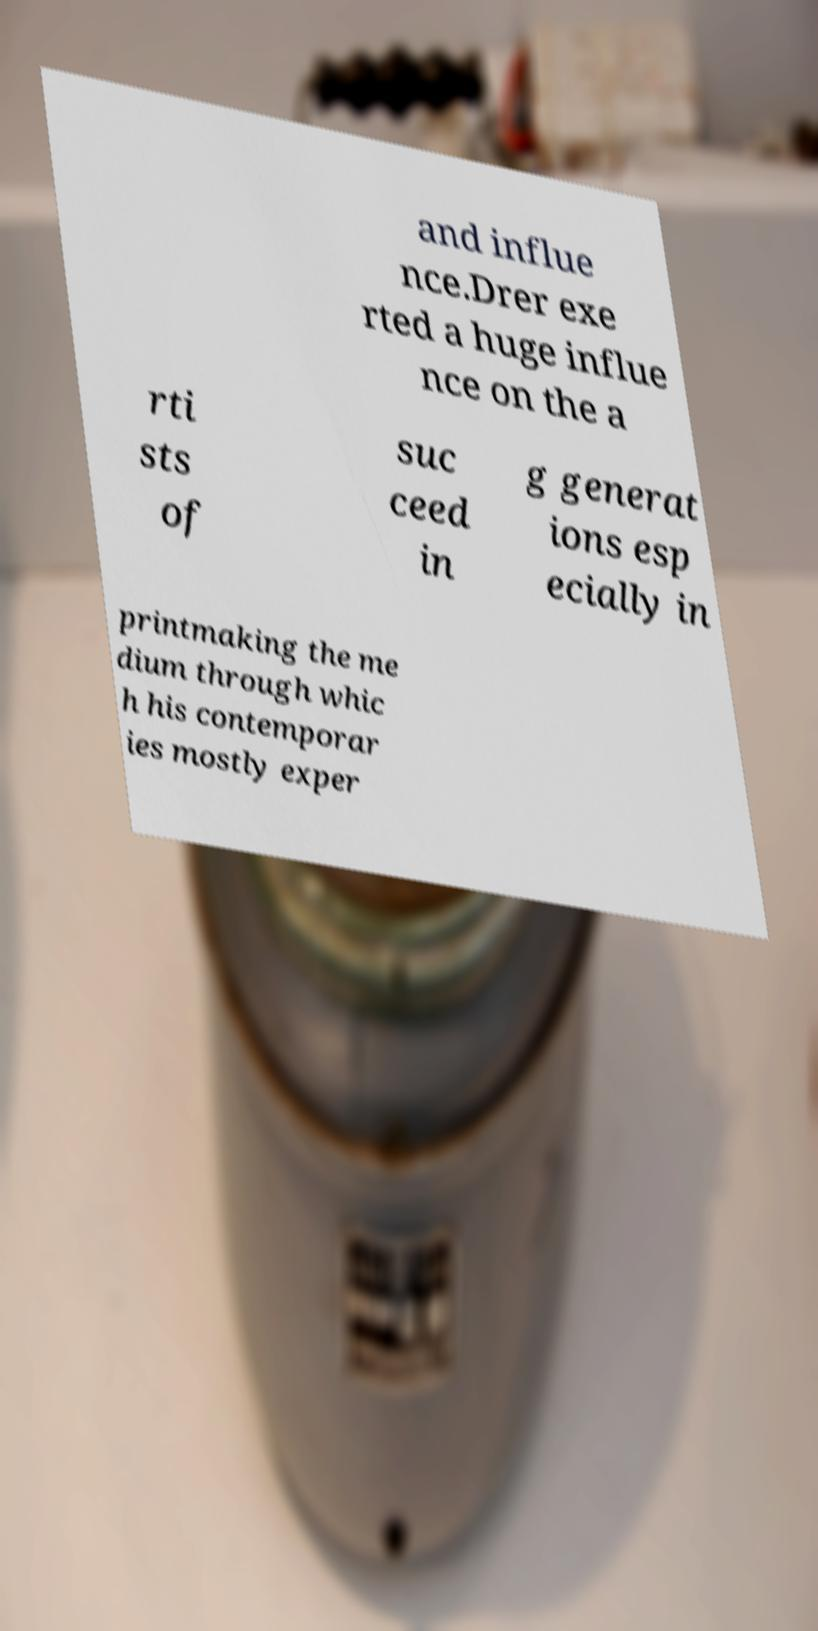There's text embedded in this image that I need extracted. Can you transcribe it verbatim? and influe nce.Drer exe rted a huge influe nce on the a rti sts of suc ceed in g generat ions esp ecially in printmaking the me dium through whic h his contemporar ies mostly exper 